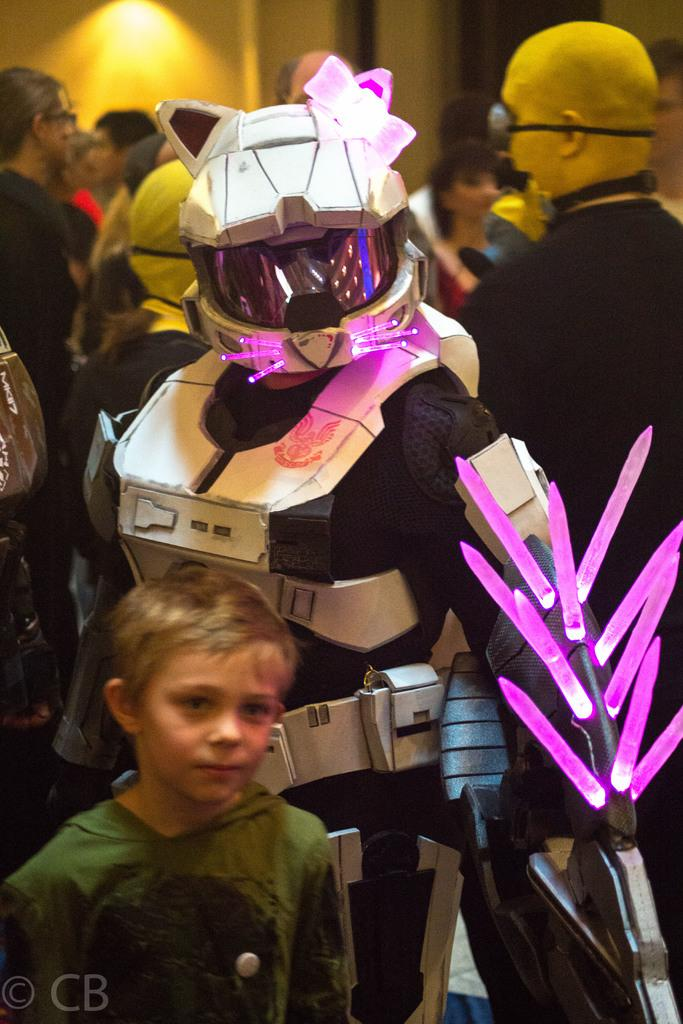What is the main subject of the image? There is a kid standing in the image. Can you describe the attire of one of the people in the image? There is a person wearing a fancy dress in the image. What can be seen in the background of the image? There are people standing in the background of the image. How can you tell that there is light in the image? There is visible light in the image. What type of writing can be seen on the ant in the image? There are no ants present in the image, and therefore no writing can be seen on them. Can you tell me how many cans are visible in the image? There are no cans visible in the image. 